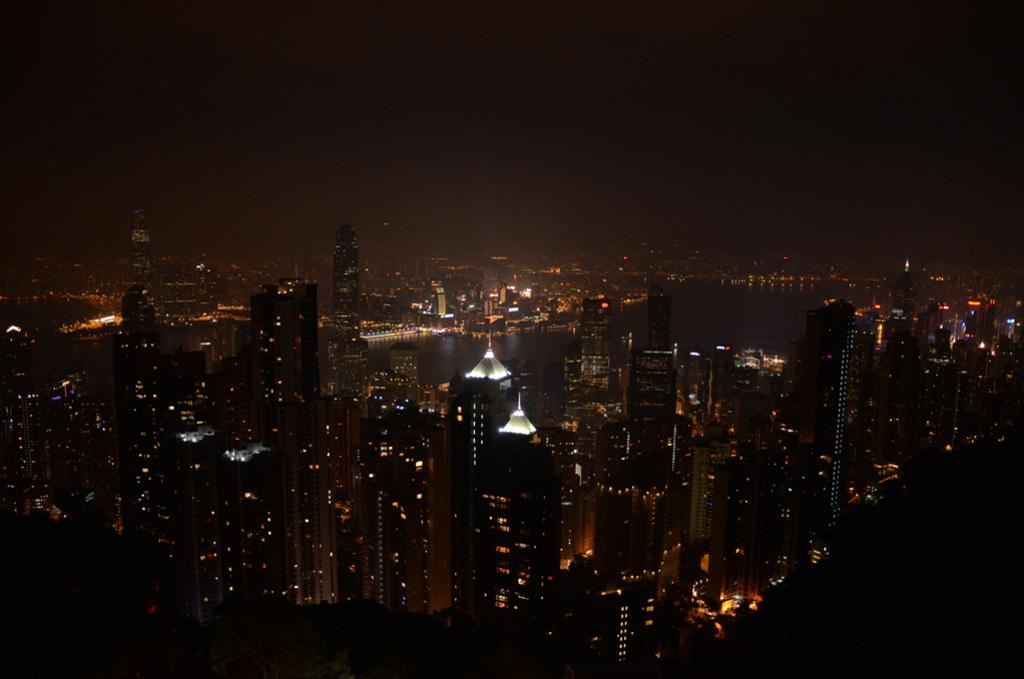What type of location is depicted in the image? The image shows a view of the city. What are some notable features of the cityscape? There are skyscrapers in the image. Are there any buildings with illumination in the image? Yes, there are buildings with lights in the image. Can you describe the sky in the image? The image likely depicts the sky, but specific details about the sky are not mentioned in the provided facts. How many horses can be seen in the image? There are no horses present in the image. What type of car is parked near the skyscrapers in the image? There is no car mentioned or visible in the image. 